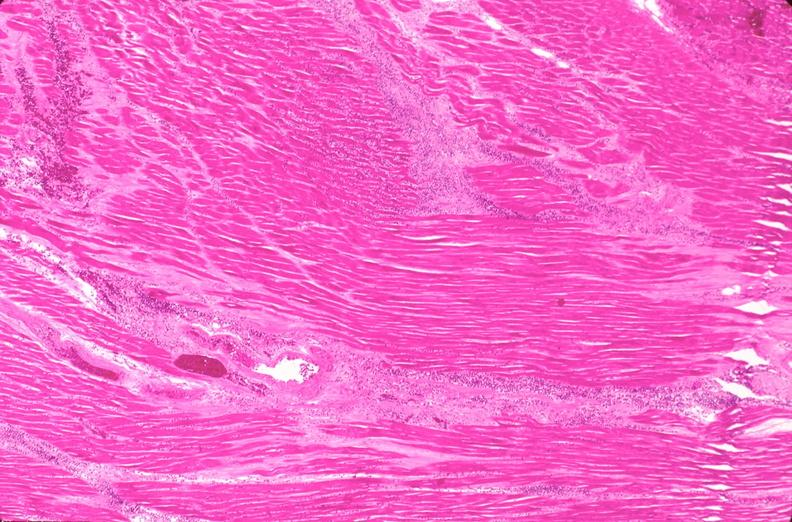does this image show heart, myocardial infarction free wall, 6 days old, in a patient with diabetes mellitus and hypertension?
Answer the question using a single word or phrase. Yes 